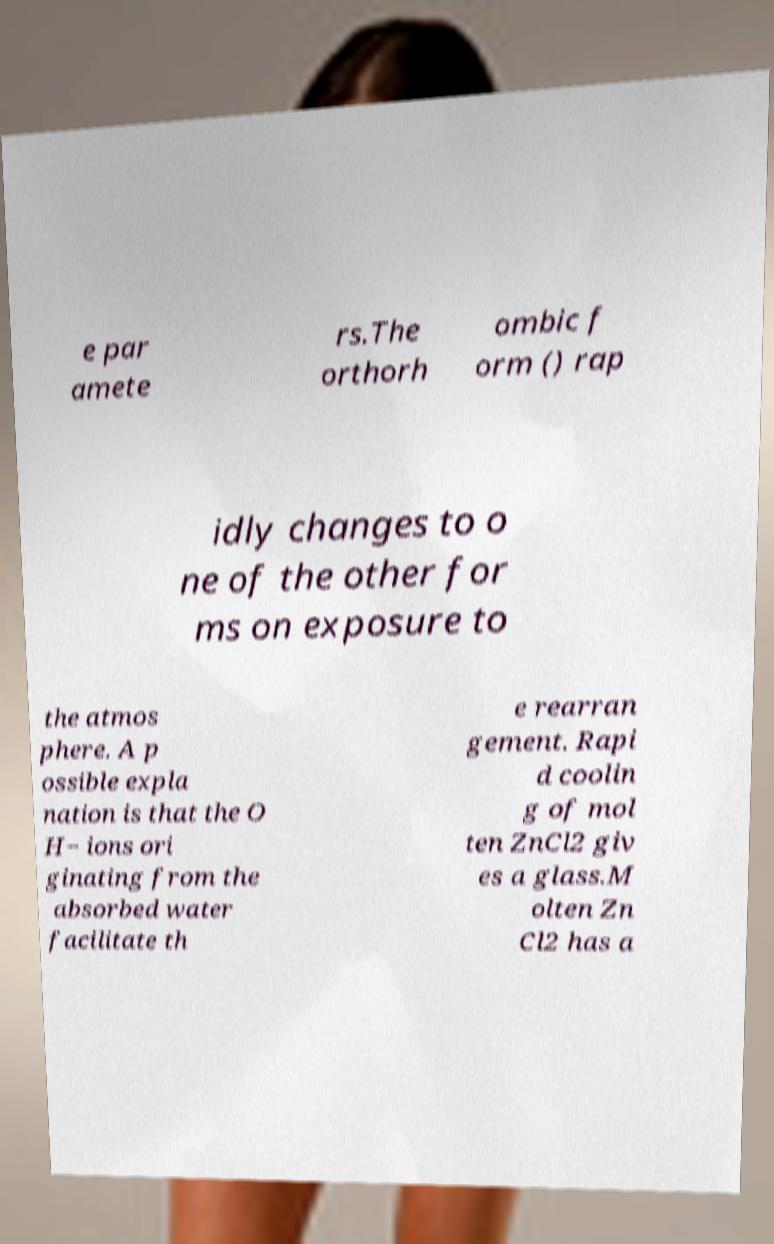Please read and relay the text visible in this image. What does it say? e par amete rs.The orthorh ombic f orm () rap idly changes to o ne of the other for ms on exposure to the atmos phere. A p ossible expla nation is that the O H− ions ori ginating from the absorbed water facilitate th e rearran gement. Rapi d coolin g of mol ten ZnCl2 giv es a glass.M olten Zn Cl2 has a 